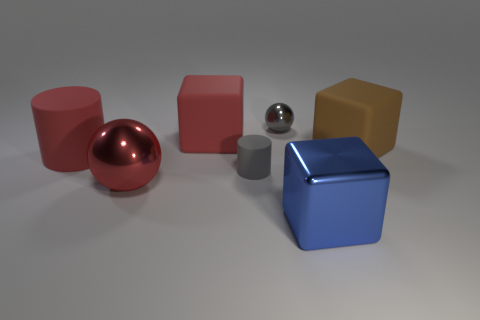Is the number of large matte things less than the number of tiny gray matte cylinders?
Provide a succinct answer. No. What color is the other metal object that is the same shape as the gray metallic object?
Provide a short and direct response. Red. The large thing that is made of the same material as the red sphere is what color?
Your answer should be very brief. Blue. What number of brown things have the same size as the blue cube?
Your answer should be compact. 1. What is the material of the large red cube?
Provide a succinct answer. Rubber. Are there more small objects than objects?
Give a very brief answer. No. Does the big blue thing have the same shape as the large brown matte thing?
Ensure brevity in your answer.  Yes. Does the cube that is left of the blue metallic thing have the same color as the metal sphere that is in front of the small gray metallic sphere?
Give a very brief answer. Yes. Is the number of rubber blocks in front of the big blue block less than the number of large red cylinders that are on the right side of the gray metal object?
Give a very brief answer. No. What is the shape of the tiny object that is left of the small metallic thing?
Offer a terse response. Cylinder. 